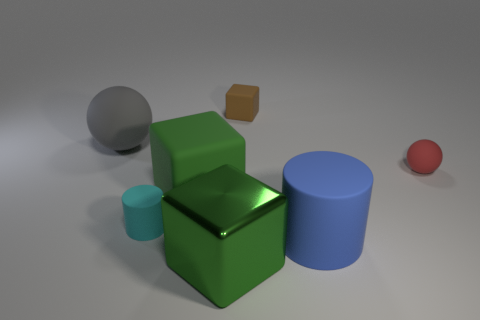What number of tiny cylinders are right of the large green cube that is in front of the large green rubber cube?
Offer a very short reply. 0. What is the shape of the large matte thing that is on the right side of the cube behind the sphere on the left side of the small sphere?
Ensure brevity in your answer.  Cylinder. The brown matte block has what size?
Provide a short and direct response. Small. Are there any brown things made of the same material as the small cylinder?
Offer a terse response. Yes. There is a green rubber thing that is the same shape as the small brown matte thing; what size is it?
Make the answer very short. Large. Are there an equal number of gray things in front of the big blue matte thing and large blue shiny balls?
Keep it short and to the point. Yes. There is a small rubber thing behind the red ball; does it have the same shape as the large green matte object?
Keep it short and to the point. Yes. The gray rubber thing has what shape?
Your response must be concise. Sphere. What is the material of the big block behind the matte cylinder that is left of the large green cube in front of the blue rubber cylinder?
Keep it short and to the point. Rubber. There is another block that is the same color as the large rubber cube; what is its material?
Ensure brevity in your answer.  Metal. 